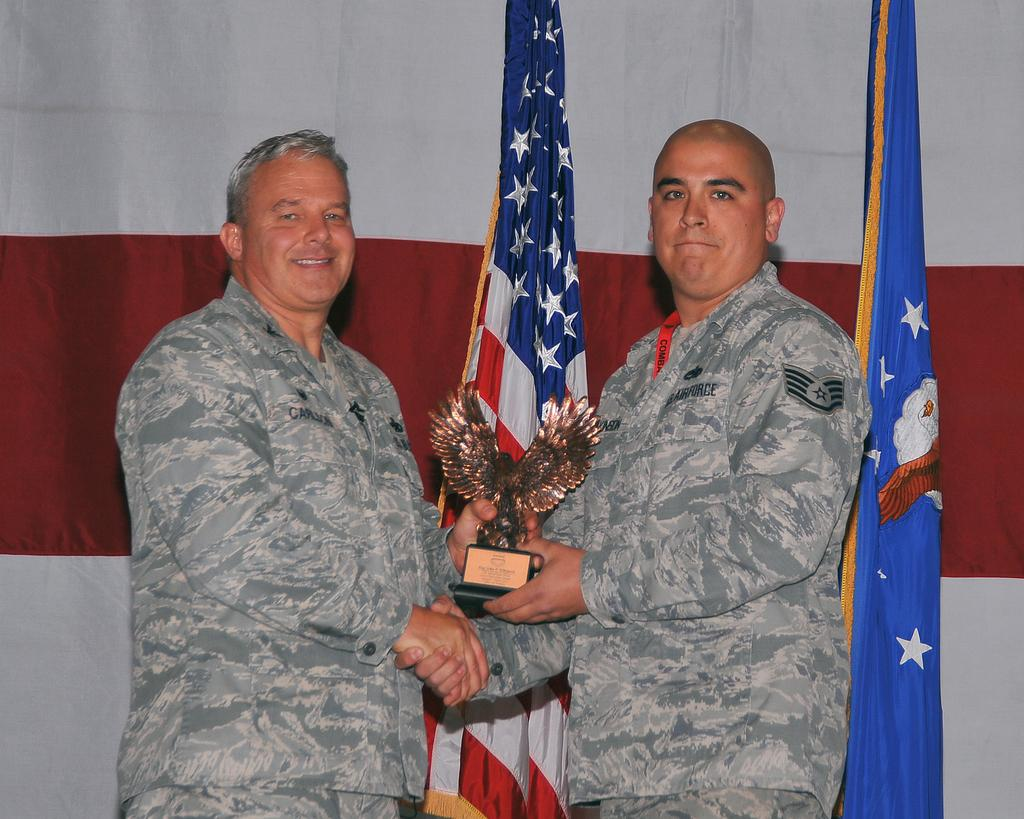How many people are present in the image? There are two persons standing in the image. What are the persons holding in their hands? The persons are holding an award in their hands. What can be seen in the background of the image? There are flags and a curtain in the background of the image. What type of quill is being used by the person on the left to express their anger in the image? There is no quill or expression of anger present in the image. 